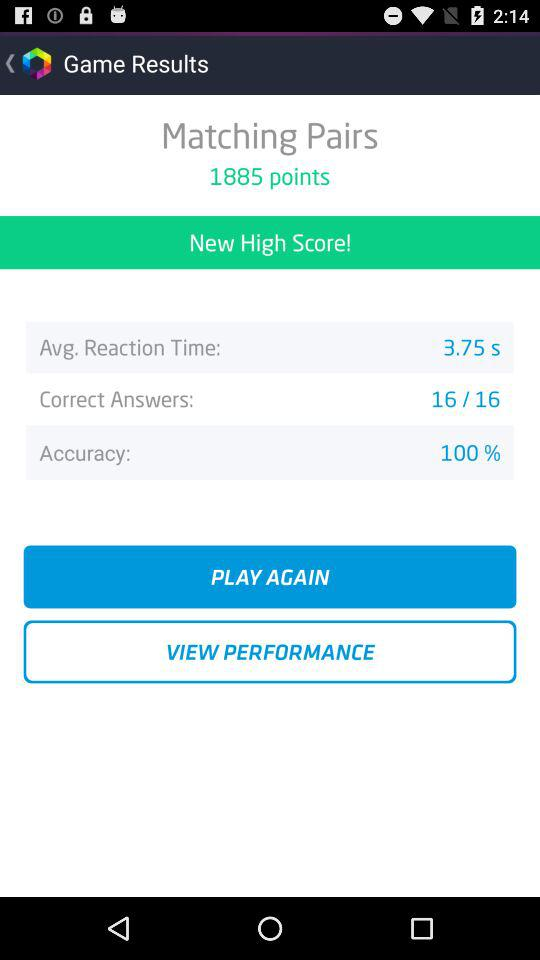What is the avg. reaction time? The average reaction time is 3.75 seconds. 